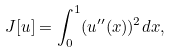Convert formula to latex. <formula><loc_0><loc_0><loc_500><loc_500>J [ u ] = \int _ { 0 } ^ { 1 } ( u ^ { \prime \prime } ( x ) ) ^ { 2 } d x ,</formula> 